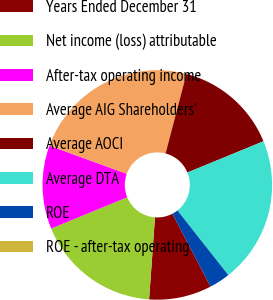<chart> <loc_0><loc_0><loc_500><loc_500><pie_chart><fcel>Years Ended December 31<fcel>Net income (loss) attributable<fcel>After-tax operating income<fcel>Average AIG Shareholders'<fcel>Average AOCI<fcel>Average DTA<fcel>ROE<fcel>ROE - after-tax operating<nl><fcel>8.82%<fcel>17.65%<fcel>11.76%<fcel>23.53%<fcel>14.71%<fcel>20.59%<fcel>2.94%<fcel>0.0%<nl></chart> 